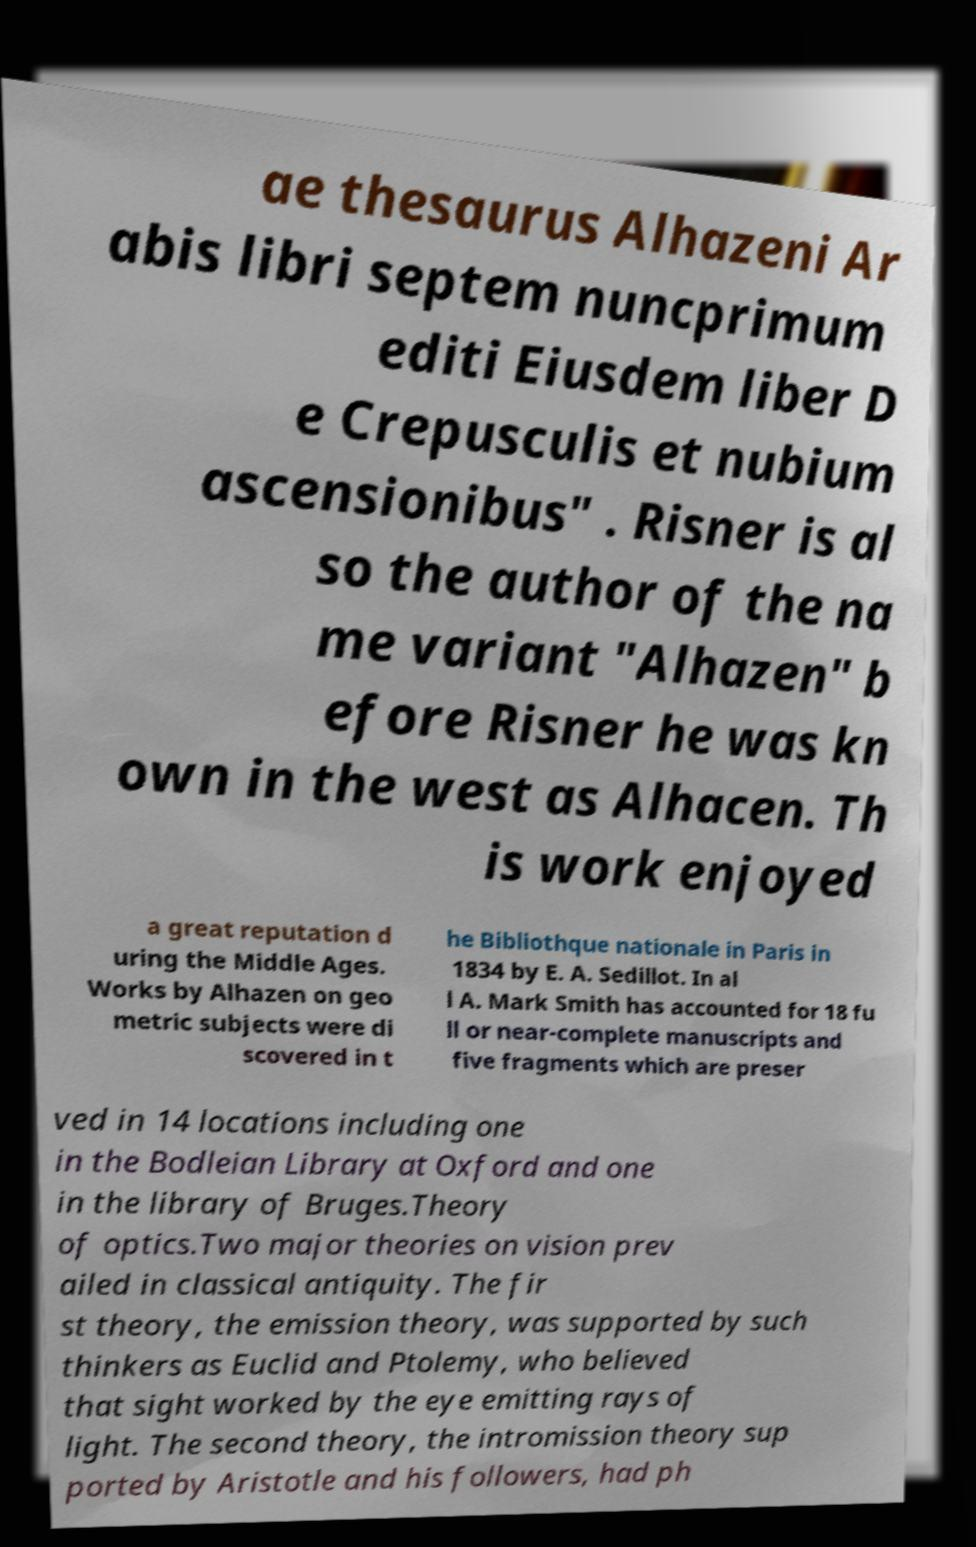Please identify and transcribe the text found in this image. ae thesaurus Alhazeni Ar abis libri septem nuncprimum editi Eiusdem liber D e Crepusculis et nubium ascensionibus" . Risner is al so the author of the na me variant "Alhazen" b efore Risner he was kn own in the west as Alhacen. Th is work enjoyed a great reputation d uring the Middle Ages. Works by Alhazen on geo metric subjects were di scovered in t he Bibliothque nationale in Paris in 1834 by E. A. Sedillot. In al l A. Mark Smith has accounted for 18 fu ll or near-complete manuscripts and five fragments which are preser ved in 14 locations including one in the Bodleian Library at Oxford and one in the library of Bruges.Theory of optics.Two major theories on vision prev ailed in classical antiquity. The fir st theory, the emission theory, was supported by such thinkers as Euclid and Ptolemy, who believed that sight worked by the eye emitting rays of light. The second theory, the intromission theory sup ported by Aristotle and his followers, had ph 